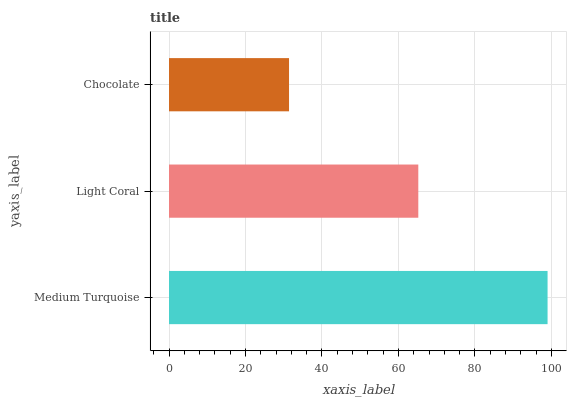Is Chocolate the minimum?
Answer yes or no. Yes. Is Medium Turquoise the maximum?
Answer yes or no. Yes. Is Light Coral the minimum?
Answer yes or no. No. Is Light Coral the maximum?
Answer yes or no. No. Is Medium Turquoise greater than Light Coral?
Answer yes or no. Yes. Is Light Coral less than Medium Turquoise?
Answer yes or no. Yes. Is Light Coral greater than Medium Turquoise?
Answer yes or no. No. Is Medium Turquoise less than Light Coral?
Answer yes or no. No. Is Light Coral the high median?
Answer yes or no. Yes. Is Light Coral the low median?
Answer yes or no. Yes. Is Medium Turquoise the high median?
Answer yes or no. No. Is Medium Turquoise the low median?
Answer yes or no. No. 